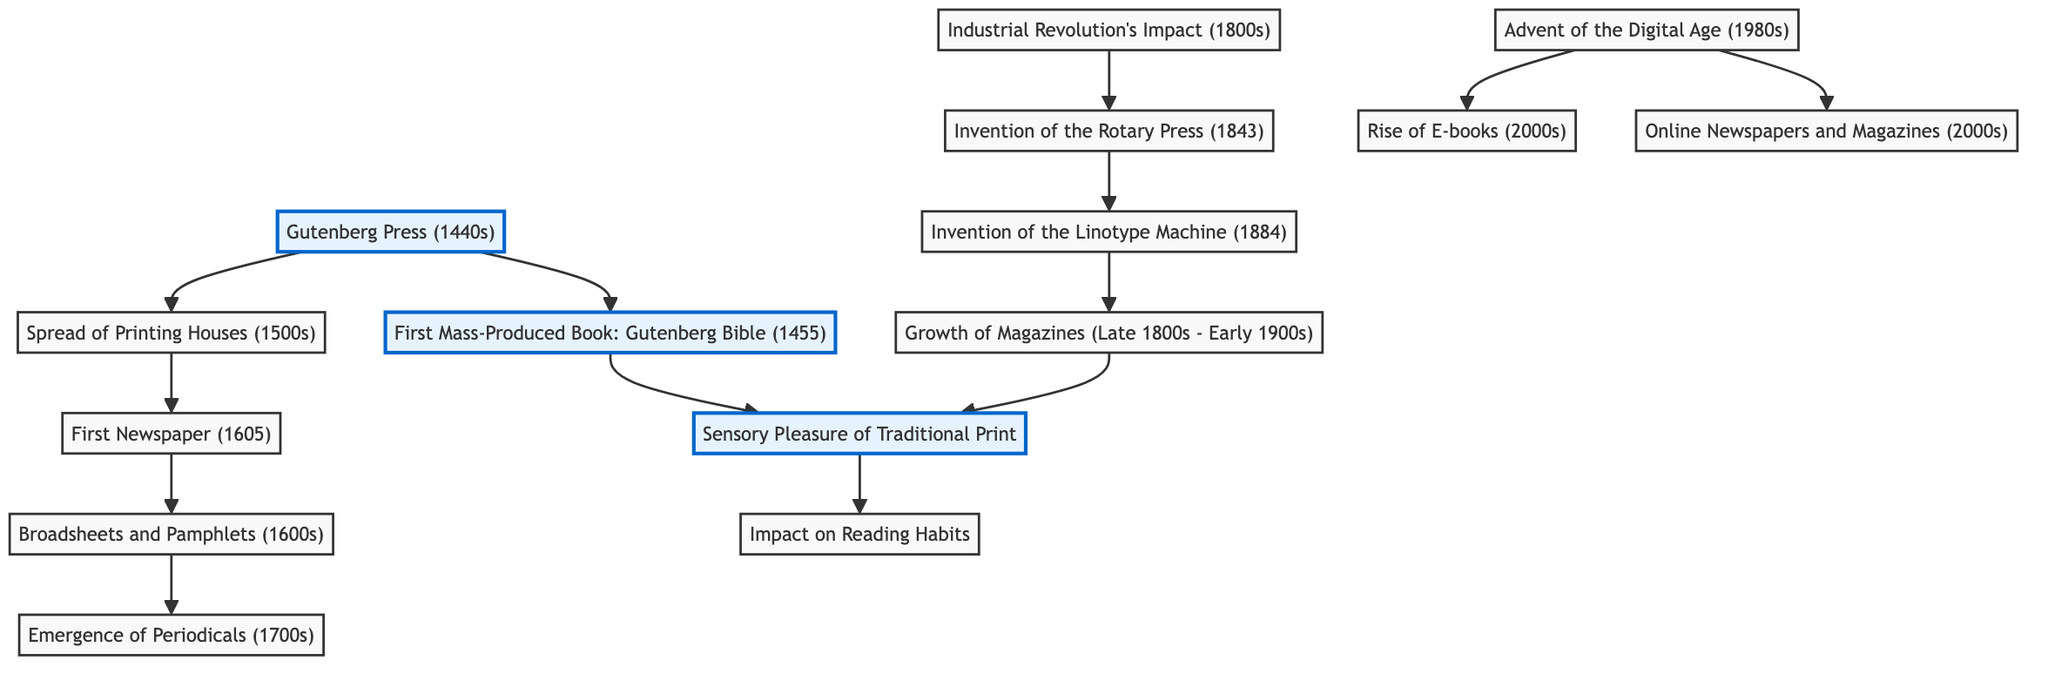What is the first mass-produced book according to the diagram? The diagram specifically identifies the "Gutenberg Bible (1455)" as the first mass-produced book, indicated by the link between the "Gutenberg Press (1440s)" and "First Mass-Produced Book".
Answer: Gutenberg Bible How many nodes are present in the diagram? By counting all the unique entities in the nodes section, there are 14 distinct nodes displayed in the diagram.
Answer: 14 Which invention links the Industrial Revolution to the development of print media? The "Invention of the Rotary Press (1843)" is shown in the diagram as a result of the Industrial Revolution's impact, demonstrating the connection made through the link.
Answer: Rotary Press What is the relationship between magazines and the sensory pleasure of traditional print? The diagram shows a direct link from "Magazines" to "Sensory Pleasure of Traditional Print", indicating that growth in magazines contributes to the sensory experience associated with print media.
Answer: Growth of Magazines How did the advent of the Digital Age affect print media? The diagram indicates the "Advent of the Digital Age (1980s)" leads to "Rise of E-books" and "Online Newspapers and Magazines", showing a transition from traditional print to digital formats.
Answer: Transition to digital formats Which invention is noted as having occurred in 1884? Referring to the timeline established in the diagram, "Invention of the Linotype Machine" is the event that occurred in the year 1884.
Answer: Linotype Machine What impact does traditional print media have on reading habits? The diagram places "Sensory Pleasure of Traditional Print" linked to the "Impact on Reading Habits", indicating that the sensory aspects of printed material influence how people read.
Answer: Impact on Reading Habits What historical event led directly to the emergence of newspapers? According to the diagram, the "Spread of Printing Houses (1500s)" directly contributes to the formation of the "First Newspaper (1605)", illustrating this historical progression.
Answer: Spread of Printing Houses What is the last major development in print media according to the diagram? The diagram indicates that the "Rise of E-books (2000s)" is the last major event listed, marking a significant step in the evolution of print media to digital formats.
Answer: Rise of E-books 